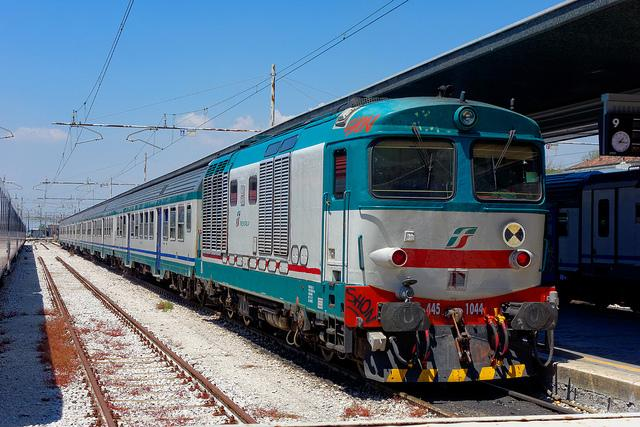What does this train carry?

Choices:
A) cars
B) passengers
C) coal
D) livestock passengers 